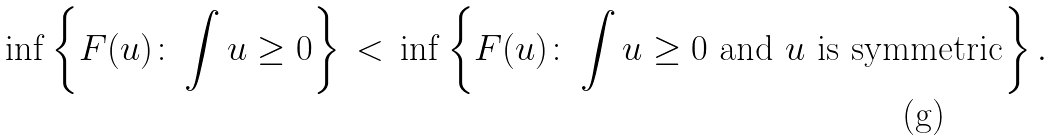Convert formula to latex. <formula><loc_0><loc_0><loc_500><loc_500>\inf \left \{ F ( u ) \colon \int u \geq 0 \right \} \, < \, \inf \left \{ F ( u ) \colon \int u \geq 0 \text { and } u \text { is symmetric} \right \} .</formula> 